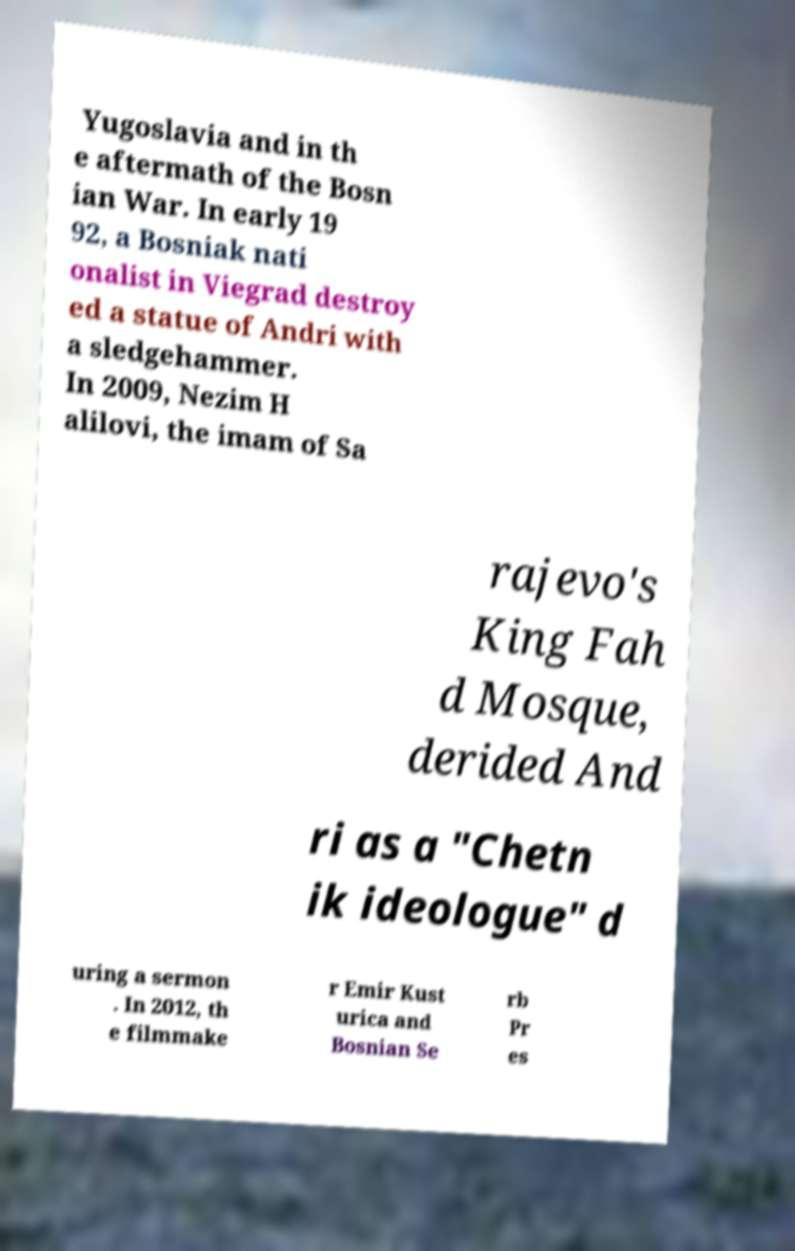What messages or text are displayed in this image? I need them in a readable, typed format. Yugoslavia and in th e aftermath of the Bosn ian War. In early 19 92, a Bosniak nati onalist in Viegrad destroy ed a statue of Andri with a sledgehammer. In 2009, Nezim H alilovi, the imam of Sa rajevo's King Fah d Mosque, derided And ri as a "Chetn ik ideologue" d uring a sermon . In 2012, th e filmmake r Emir Kust urica and Bosnian Se rb Pr es 